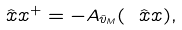Convert formula to latex. <formula><loc_0><loc_0><loc_500><loc_500>\hat { \ x x } ^ { + } = - A _ { \hat { v } _ { M } } ( \hat { \ x x } ) ,</formula> 